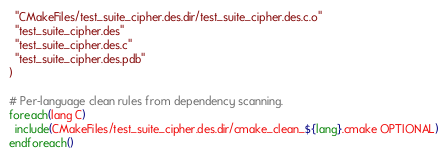<code> <loc_0><loc_0><loc_500><loc_500><_CMake_>  "CMakeFiles/test_suite_cipher.des.dir/test_suite_cipher.des.c.o"
  "test_suite_cipher.des"
  "test_suite_cipher.des.c"
  "test_suite_cipher.des.pdb"
)

# Per-language clean rules from dependency scanning.
foreach(lang C)
  include(CMakeFiles/test_suite_cipher.des.dir/cmake_clean_${lang}.cmake OPTIONAL)
endforeach()
</code> 